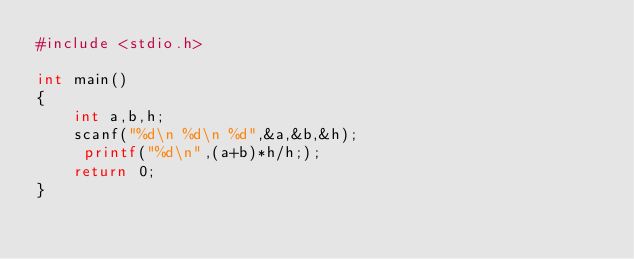Convert code to text. <code><loc_0><loc_0><loc_500><loc_500><_Awk_>#include <stdio.h>

int main()
{
    int a,b,h;
    scanf("%d\n %d\n %d",&a,&b,&h);
     printf("%d\n",(a+b)*h/h;);
    return 0;
}
</code> 